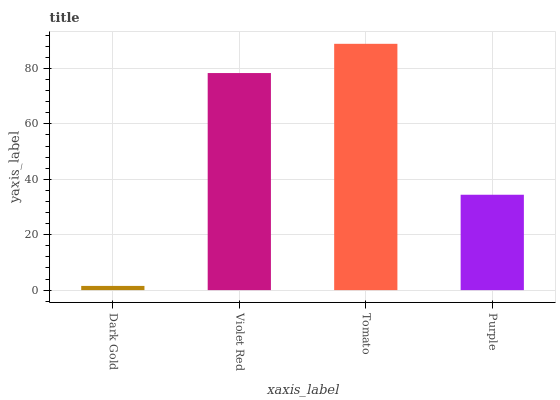Is Violet Red the minimum?
Answer yes or no. No. Is Violet Red the maximum?
Answer yes or no. No. Is Violet Red greater than Dark Gold?
Answer yes or no. Yes. Is Dark Gold less than Violet Red?
Answer yes or no. Yes. Is Dark Gold greater than Violet Red?
Answer yes or no. No. Is Violet Red less than Dark Gold?
Answer yes or no. No. Is Violet Red the high median?
Answer yes or no. Yes. Is Purple the low median?
Answer yes or no. Yes. Is Dark Gold the high median?
Answer yes or no. No. Is Dark Gold the low median?
Answer yes or no. No. 